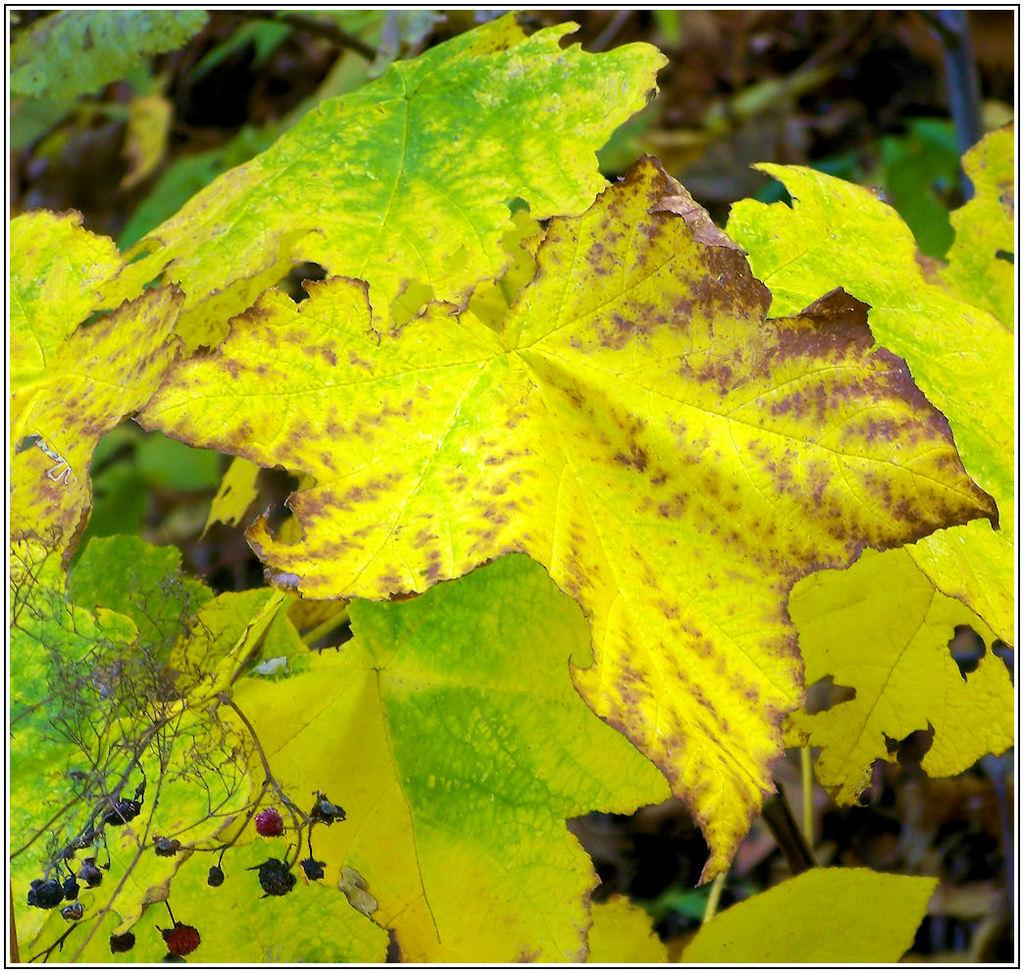What type of natural elements can be seen in the image? There are leaves in the image. Can you describe the colors of the leaves? The leaves are in green and yellowish colors. How many people are jumping in the cave with a kettle in the image? There are no people, caves, or kettles present in the image; it only features leaves in green and yellowish colors. 